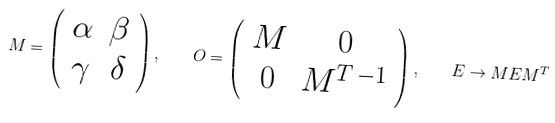<formula> <loc_0><loc_0><loc_500><loc_500>M = \left ( \begin{array} { c c } \alpha & \beta \\ \gamma & \delta \end{array} \right ) , \quad O = \left ( \begin{array} { c c } M & 0 \\ 0 & M ^ { T \, - 1 } \end{array} \right ) , \quad E \rightarrow M E M ^ { T }</formula> 